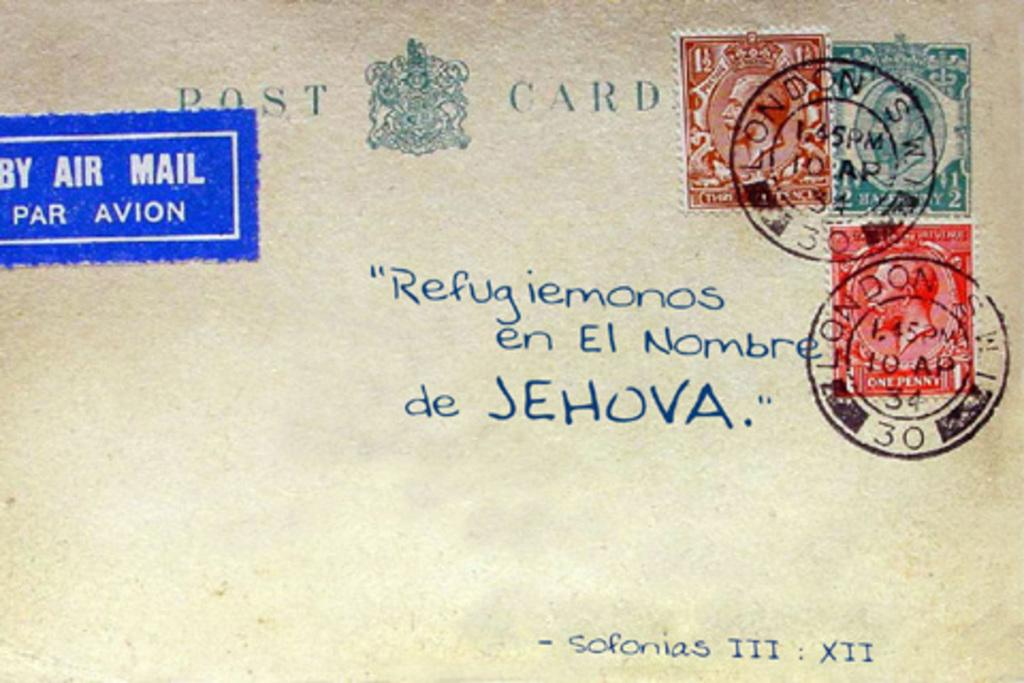<image>
Write a terse but informative summary of the picture. a postal card that has the word Jehova on it 